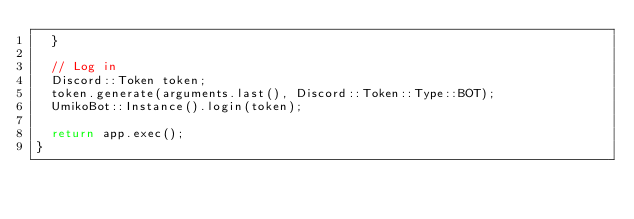<code> <loc_0><loc_0><loc_500><loc_500><_C++_>	}

	// Log in
	Discord::Token token;
	token.generate(arguments.last(), Discord::Token::Type::BOT);
	UmikoBot::Instance().login(token);

	return app.exec();
}
</code> 